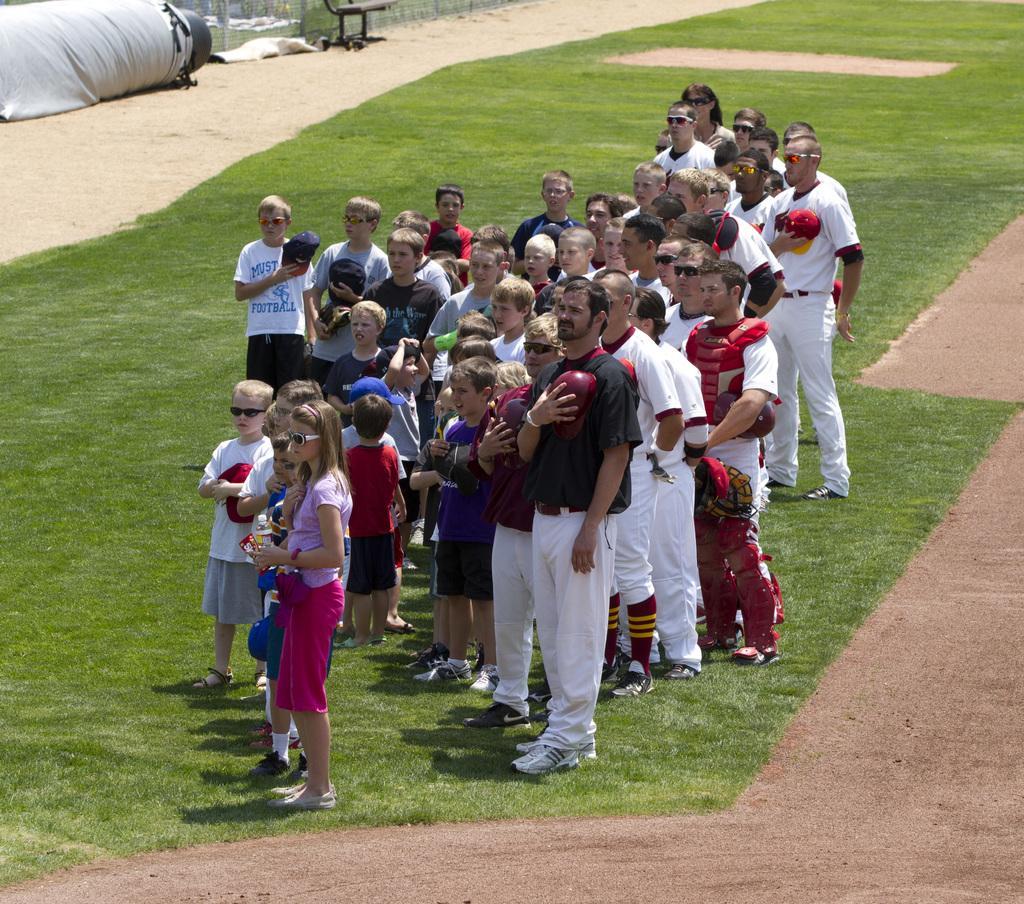How would you summarize this image in a sentence or two? In this picture there are group of people standing on the grass. At the back there is a fence and chair. At the bottom there is grass and there is mud. 